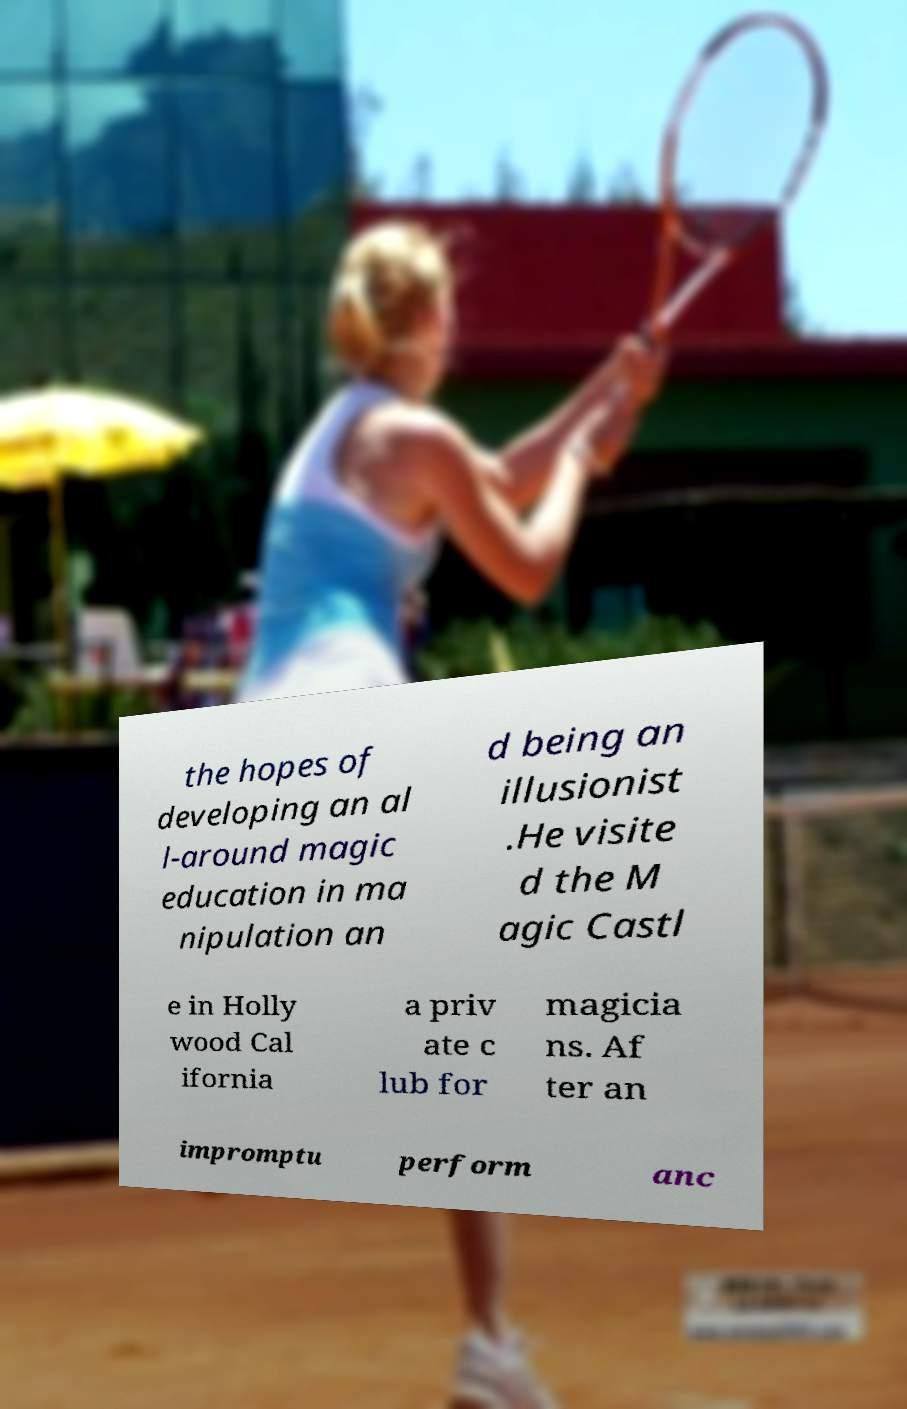Could you assist in decoding the text presented in this image and type it out clearly? the hopes of developing an al l-around magic education in ma nipulation an d being an illusionist .He visite d the M agic Castl e in Holly wood Cal ifornia a priv ate c lub for magicia ns. Af ter an impromptu perform anc 